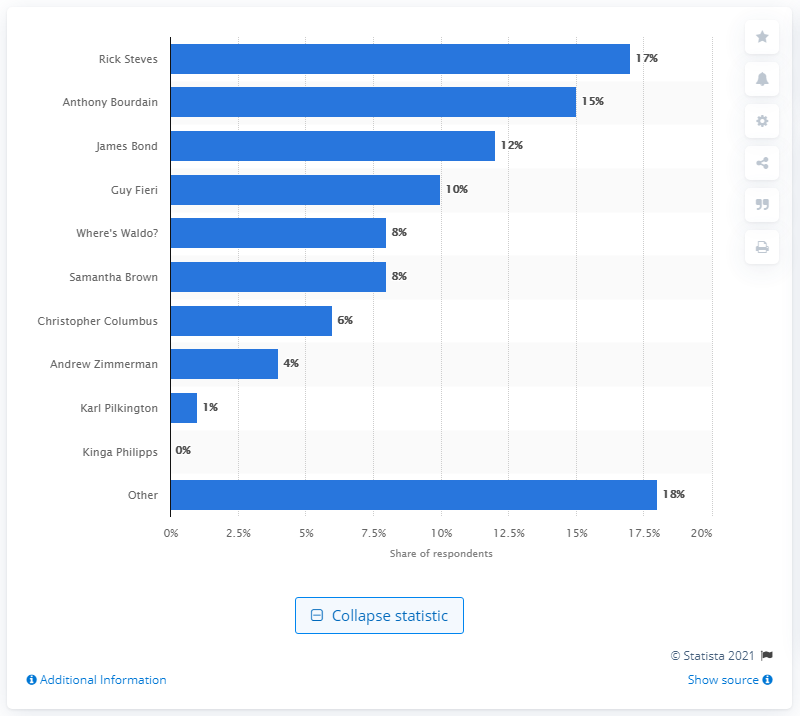Point out several critical features in this image. Rick Steves is the most popular travel role model in the United States. 